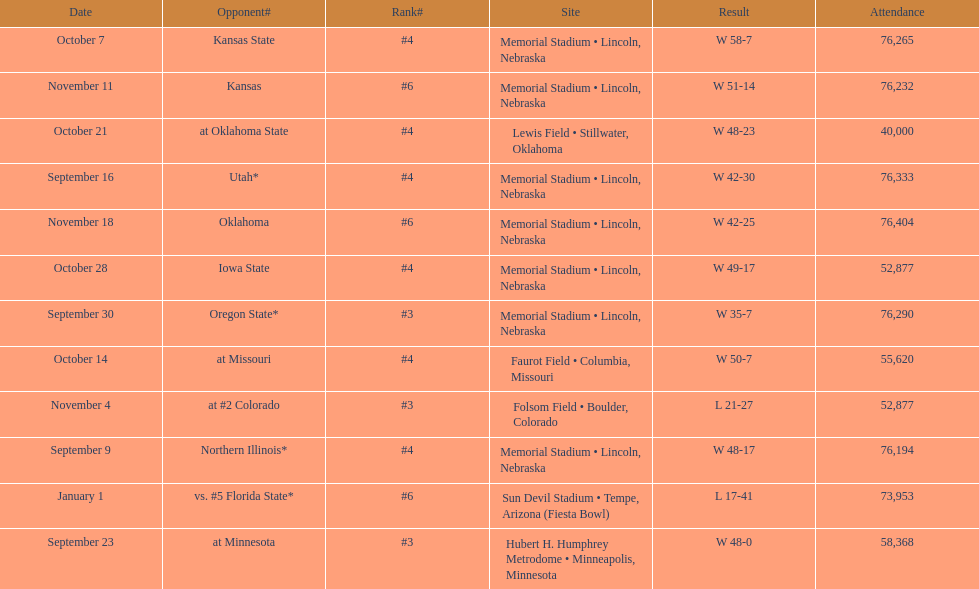How many games did they win by more than 7? 10. 